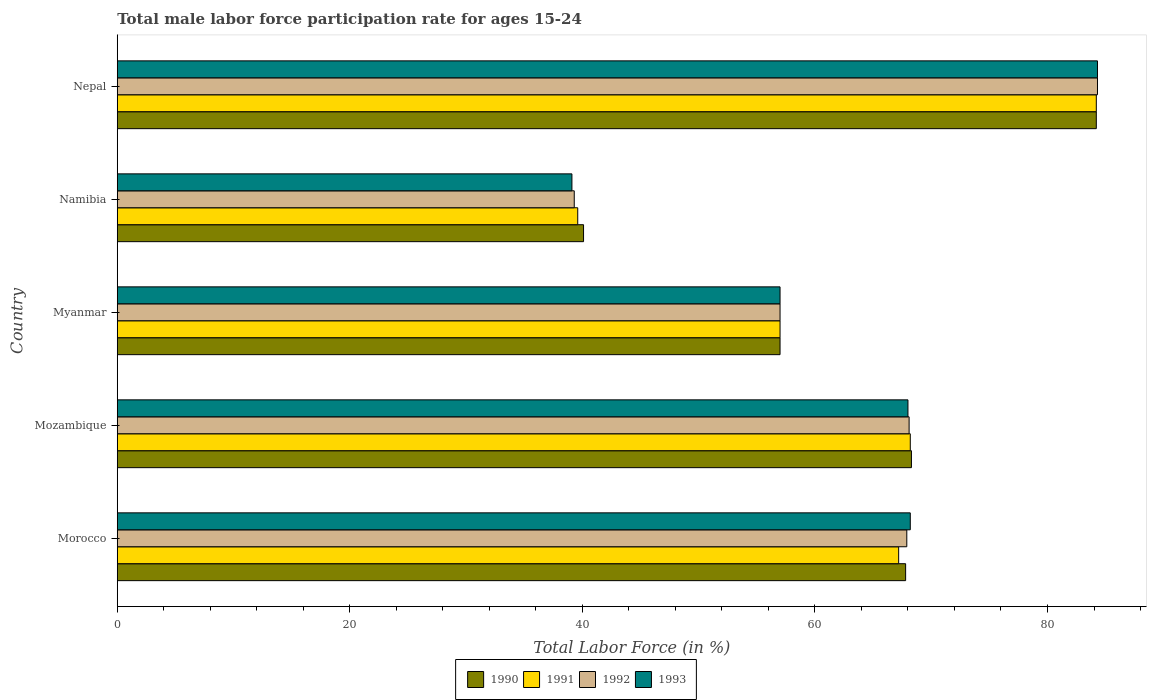How many groups of bars are there?
Offer a terse response. 5. Are the number of bars per tick equal to the number of legend labels?
Your answer should be very brief. Yes. How many bars are there on the 3rd tick from the bottom?
Ensure brevity in your answer.  4. What is the label of the 2nd group of bars from the top?
Offer a terse response. Namibia. In how many cases, is the number of bars for a given country not equal to the number of legend labels?
Provide a short and direct response. 0. What is the male labor force participation rate in 1990 in Mozambique?
Your answer should be very brief. 68.3. Across all countries, what is the maximum male labor force participation rate in 1990?
Provide a succinct answer. 84.2. Across all countries, what is the minimum male labor force participation rate in 1992?
Your answer should be compact. 39.3. In which country was the male labor force participation rate in 1992 maximum?
Provide a succinct answer. Nepal. In which country was the male labor force participation rate in 1991 minimum?
Keep it short and to the point. Namibia. What is the total male labor force participation rate in 1993 in the graph?
Give a very brief answer. 316.6. What is the difference between the male labor force participation rate in 1993 in Morocco and that in Namibia?
Make the answer very short. 29.1. What is the difference between the male labor force participation rate in 1992 in Mozambique and the male labor force participation rate in 1993 in Myanmar?
Make the answer very short. 11.1. What is the average male labor force participation rate in 1991 per country?
Your answer should be very brief. 63.24. In how many countries, is the male labor force participation rate in 1993 greater than 84 %?
Keep it short and to the point. 1. What is the ratio of the male labor force participation rate in 1990 in Morocco to that in Nepal?
Provide a short and direct response. 0.81. Is the difference between the male labor force participation rate in 1992 in Morocco and Myanmar greater than the difference between the male labor force participation rate in 1993 in Morocco and Myanmar?
Offer a very short reply. No. What is the difference between the highest and the lowest male labor force participation rate in 1990?
Make the answer very short. 44.1. In how many countries, is the male labor force participation rate in 1991 greater than the average male labor force participation rate in 1991 taken over all countries?
Provide a succinct answer. 3. Is the sum of the male labor force participation rate in 1991 in Myanmar and Namibia greater than the maximum male labor force participation rate in 1992 across all countries?
Provide a short and direct response. Yes. What does the 4th bar from the top in Myanmar represents?
Give a very brief answer. 1990. Is it the case that in every country, the sum of the male labor force participation rate in 1991 and male labor force participation rate in 1990 is greater than the male labor force participation rate in 1992?
Your response must be concise. Yes. How many countries are there in the graph?
Offer a terse response. 5. What is the difference between two consecutive major ticks on the X-axis?
Make the answer very short. 20. Does the graph contain any zero values?
Your answer should be very brief. No. Where does the legend appear in the graph?
Give a very brief answer. Bottom center. What is the title of the graph?
Provide a short and direct response. Total male labor force participation rate for ages 15-24. What is the label or title of the X-axis?
Your answer should be very brief. Total Labor Force (in %). What is the Total Labor Force (in %) of 1990 in Morocco?
Offer a terse response. 67.8. What is the Total Labor Force (in %) of 1991 in Morocco?
Your response must be concise. 67.2. What is the Total Labor Force (in %) in 1992 in Morocco?
Provide a succinct answer. 67.9. What is the Total Labor Force (in %) of 1993 in Morocco?
Offer a terse response. 68.2. What is the Total Labor Force (in %) of 1990 in Mozambique?
Provide a short and direct response. 68.3. What is the Total Labor Force (in %) of 1991 in Mozambique?
Make the answer very short. 68.2. What is the Total Labor Force (in %) in 1992 in Mozambique?
Offer a terse response. 68.1. What is the Total Labor Force (in %) of 1990 in Myanmar?
Provide a short and direct response. 57. What is the Total Labor Force (in %) of 1991 in Myanmar?
Offer a very short reply. 57. What is the Total Labor Force (in %) in 1993 in Myanmar?
Your answer should be compact. 57. What is the Total Labor Force (in %) of 1990 in Namibia?
Your answer should be compact. 40.1. What is the Total Labor Force (in %) in 1991 in Namibia?
Keep it short and to the point. 39.6. What is the Total Labor Force (in %) of 1992 in Namibia?
Provide a succinct answer. 39.3. What is the Total Labor Force (in %) of 1993 in Namibia?
Your answer should be compact. 39.1. What is the Total Labor Force (in %) in 1990 in Nepal?
Provide a succinct answer. 84.2. What is the Total Labor Force (in %) in 1991 in Nepal?
Give a very brief answer. 84.2. What is the Total Labor Force (in %) of 1992 in Nepal?
Offer a very short reply. 84.3. What is the Total Labor Force (in %) of 1993 in Nepal?
Offer a very short reply. 84.3. Across all countries, what is the maximum Total Labor Force (in %) in 1990?
Offer a terse response. 84.2. Across all countries, what is the maximum Total Labor Force (in %) of 1991?
Provide a short and direct response. 84.2. Across all countries, what is the maximum Total Labor Force (in %) in 1992?
Your answer should be very brief. 84.3. Across all countries, what is the maximum Total Labor Force (in %) of 1993?
Offer a very short reply. 84.3. Across all countries, what is the minimum Total Labor Force (in %) of 1990?
Your answer should be very brief. 40.1. Across all countries, what is the minimum Total Labor Force (in %) of 1991?
Your answer should be compact. 39.6. Across all countries, what is the minimum Total Labor Force (in %) in 1992?
Make the answer very short. 39.3. Across all countries, what is the minimum Total Labor Force (in %) of 1993?
Ensure brevity in your answer.  39.1. What is the total Total Labor Force (in %) of 1990 in the graph?
Offer a terse response. 317.4. What is the total Total Labor Force (in %) of 1991 in the graph?
Keep it short and to the point. 316.2. What is the total Total Labor Force (in %) of 1992 in the graph?
Give a very brief answer. 316.6. What is the total Total Labor Force (in %) in 1993 in the graph?
Your response must be concise. 316.6. What is the difference between the Total Labor Force (in %) in 1991 in Morocco and that in Mozambique?
Provide a succinct answer. -1. What is the difference between the Total Labor Force (in %) in 1990 in Morocco and that in Myanmar?
Offer a terse response. 10.8. What is the difference between the Total Labor Force (in %) of 1990 in Morocco and that in Namibia?
Provide a short and direct response. 27.7. What is the difference between the Total Labor Force (in %) of 1991 in Morocco and that in Namibia?
Ensure brevity in your answer.  27.6. What is the difference between the Total Labor Force (in %) in 1992 in Morocco and that in Namibia?
Your answer should be very brief. 28.6. What is the difference between the Total Labor Force (in %) of 1993 in Morocco and that in Namibia?
Ensure brevity in your answer.  29.1. What is the difference between the Total Labor Force (in %) of 1990 in Morocco and that in Nepal?
Offer a very short reply. -16.4. What is the difference between the Total Labor Force (in %) in 1992 in Morocco and that in Nepal?
Ensure brevity in your answer.  -16.4. What is the difference between the Total Labor Force (in %) of 1993 in Morocco and that in Nepal?
Make the answer very short. -16.1. What is the difference between the Total Labor Force (in %) in 1992 in Mozambique and that in Myanmar?
Offer a very short reply. 11.1. What is the difference between the Total Labor Force (in %) in 1993 in Mozambique and that in Myanmar?
Provide a short and direct response. 11. What is the difference between the Total Labor Force (in %) of 1990 in Mozambique and that in Namibia?
Provide a succinct answer. 28.2. What is the difference between the Total Labor Force (in %) in 1991 in Mozambique and that in Namibia?
Offer a terse response. 28.6. What is the difference between the Total Labor Force (in %) in 1992 in Mozambique and that in Namibia?
Give a very brief answer. 28.8. What is the difference between the Total Labor Force (in %) of 1993 in Mozambique and that in Namibia?
Your response must be concise. 28.9. What is the difference between the Total Labor Force (in %) of 1990 in Mozambique and that in Nepal?
Give a very brief answer. -15.9. What is the difference between the Total Labor Force (in %) in 1992 in Mozambique and that in Nepal?
Your response must be concise. -16.2. What is the difference between the Total Labor Force (in %) of 1993 in Mozambique and that in Nepal?
Your answer should be very brief. -16.3. What is the difference between the Total Labor Force (in %) of 1991 in Myanmar and that in Namibia?
Offer a terse response. 17.4. What is the difference between the Total Labor Force (in %) in 1992 in Myanmar and that in Namibia?
Keep it short and to the point. 17.7. What is the difference between the Total Labor Force (in %) of 1990 in Myanmar and that in Nepal?
Ensure brevity in your answer.  -27.2. What is the difference between the Total Labor Force (in %) in 1991 in Myanmar and that in Nepal?
Your answer should be very brief. -27.2. What is the difference between the Total Labor Force (in %) of 1992 in Myanmar and that in Nepal?
Provide a short and direct response. -27.3. What is the difference between the Total Labor Force (in %) in 1993 in Myanmar and that in Nepal?
Ensure brevity in your answer.  -27.3. What is the difference between the Total Labor Force (in %) of 1990 in Namibia and that in Nepal?
Your answer should be very brief. -44.1. What is the difference between the Total Labor Force (in %) in 1991 in Namibia and that in Nepal?
Keep it short and to the point. -44.6. What is the difference between the Total Labor Force (in %) of 1992 in Namibia and that in Nepal?
Offer a terse response. -45. What is the difference between the Total Labor Force (in %) in 1993 in Namibia and that in Nepal?
Provide a succinct answer. -45.2. What is the difference between the Total Labor Force (in %) in 1990 in Morocco and the Total Labor Force (in %) in 1991 in Mozambique?
Provide a short and direct response. -0.4. What is the difference between the Total Labor Force (in %) of 1991 in Morocco and the Total Labor Force (in %) of 1992 in Mozambique?
Provide a succinct answer. -0.9. What is the difference between the Total Labor Force (in %) in 1992 in Morocco and the Total Labor Force (in %) in 1993 in Mozambique?
Provide a succinct answer. -0.1. What is the difference between the Total Labor Force (in %) of 1990 in Morocco and the Total Labor Force (in %) of 1993 in Myanmar?
Keep it short and to the point. 10.8. What is the difference between the Total Labor Force (in %) of 1991 in Morocco and the Total Labor Force (in %) of 1992 in Myanmar?
Make the answer very short. 10.2. What is the difference between the Total Labor Force (in %) in 1991 in Morocco and the Total Labor Force (in %) in 1993 in Myanmar?
Provide a succinct answer. 10.2. What is the difference between the Total Labor Force (in %) in 1990 in Morocco and the Total Labor Force (in %) in 1991 in Namibia?
Make the answer very short. 28.2. What is the difference between the Total Labor Force (in %) of 1990 in Morocco and the Total Labor Force (in %) of 1992 in Namibia?
Make the answer very short. 28.5. What is the difference between the Total Labor Force (in %) of 1990 in Morocco and the Total Labor Force (in %) of 1993 in Namibia?
Provide a succinct answer. 28.7. What is the difference between the Total Labor Force (in %) of 1991 in Morocco and the Total Labor Force (in %) of 1992 in Namibia?
Your response must be concise. 27.9. What is the difference between the Total Labor Force (in %) in 1991 in Morocco and the Total Labor Force (in %) in 1993 in Namibia?
Ensure brevity in your answer.  28.1. What is the difference between the Total Labor Force (in %) of 1992 in Morocco and the Total Labor Force (in %) of 1993 in Namibia?
Offer a terse response. 28.8. What is the difference between the Total Labor Force (in %) in 1990 in Morocco and the Total Labor Force (in %) in 1991 in Nepal?
Your answer should be very brief. -16.4. What is the difference between the Total Labor Force (in %) in 1990 in Morocco and the Total Labor Force (in %) in 1992 in Nepal?
Make the answer very short. -16.5. What is the difference between the Total Labor Force (in %) in 1990 in Morocco and the Total Labor Force (in %) in 1993 in Nepal?
Your response must be concise. -16.5. What is the difference between the Total Labor Force (in %) of 1991 in Morocco and the Total Labor Force (in %) of 1992 in Nepal?
Keep it short and to the point. -17.1. What is the difference between the Total Labor Force (in %) in 1991 in Morocco and the Total Labor Force (in %) in 1993 in Nepal?
Ensure brevity in your answer.  -17.1. What is the difference between the Total Labor Force (in %) in 1992 in Morocco and the Total Labor Force (in %) in 1993 in Nepal?
Offer a terse response. -16.4. What is the difference between the Total Labor Force (in %) of 1990 in Mozambique and the Total Labor Force (in %) of 1991 in Myanmar?
Your response must be concise. 11.3. What is the difference between the Total Labor Force (in %) in 1990 in Mozambique and the Total Labor Force (in %) in 1992 in Myanmar?
Ensure brevity in your answer.  11.3. What is the difference between the Total Labor Force (in %) of 1991 in Mozambique and the Total Labor Force (in %) of 1992 in Myanmar?
Ensure brevity in your answer.  11.2. What is the difference between the Total Labor Force (in %) in 1991 in Mozambique and the Total Labor Force (in %) in 1993 in Myanmar?
Make the answer very short. 11.2. What is the difference between the Total Labor Force (in %) in 1990 in Mozambique and the Total Labor Force (in %) in 1991 in Namibia?
Offer a terse response. 28.7. What is the difference between the Total Labor Force (in %) of 1990 in Mozambique and the Total Labor Force (in %) of 1992 in Namibia?
Provide a succinct answer. 29. What is the difference between the Total Labor Force (in %) in 1990 in Mozambique and the Total Labor Force (in %) in 1993 in Namibia?
Provide a short and direct response. 29.2. What is the difference between the Total Labor Force (in %) of 1991 in Mozambique and the Total Labor Force (in %) of 1992 in Namibia?
Offer a very short reply. 28.9. What is the difference between the Total Labor Force (in %) in 1991 in Mozambique and the Total Labor Force (in %) in 1993 in Namibia?
Offer a terse response. 29.1. What is the difference between the Total Labor Force (in %) of 1992 in Mozambique and the Total Labor Force (in %) of 1993 in Namibia?
Your answer should be very brief. 29. What is the difference between the Total Labor Force (in %) of 1990 in Mozambique and the Total Labor Force (in %) of 1991 in Nepal?
Ensure brevity in your answer.  -15.9. What is the difference between the Total Labor Force (in %) of 1990 in Mozambique and the Total Labor Force (in %) of 1992 in Nepal?
Your response must be concise. -16. What is the difference between the Total Labor Force (in %) in 1990 in Mozambique and the Total Labor Force (in %) in 1993 in Nepal?
Your response must be concise. -16. What is the difference between the Total Labor Force (in %) of 1991 in Mozambique and the Total Labor Force (in %) of 1992 in Nepal?
Your answer should be very brief. -16.1. What is the difference between the Total Labor Force (in %) of 1991 in Mozambique and the Total Labor Force (in %) of 1993 in Nepal?
Keep it short and to the point. -16.1. What is the difference between the Total Labor Force (in %) in 1992 in Mozambique and the Total Labor Force (in %) in 1993 in Nepal?
Give a very brief answer. -16.2. What is the difference between the Total Labor Force (in %) of 1990 in Myanmar and the Total Labor Force (in %) of 1991 in Namibia?
Offer a very short reply. 17.4. What is the difference between the Total Labor Force (in %) of 1990 in Myanmar and the Total Labor Force (in %) of 1992 in Namibia?
Offer a terse response. 17.7. What is the difference between the Total Labor Force (in %) in 1990 in Myanmar and the Total Labor Force (in %) in 1991 in Nepal?
Provide a succinct answer. -27.2. What is the difference between the Total Labor Force (in %) of 1990 in Myanmar and the Total Labor Force (in %) of 1992 in Nepal?
Make the answer very short. -27.3. What is the difference between the Total Labor Force (in %) of 1990 in Myanmar and the Total Labor Force (in %) of 1993 in Nepal?
Give a very brief answer. -27.3. What is the difference between the Total Labor Force (in %) of 1991 in Myanmar and the Total Labor Force (in %) of 1992 in Nepal?
Provide a short and direct response. -27.3. What is the difference between the Total Labor Force (in %) of 1991 in Myanmar and the Total Labor Force (in %) of 1993 in Nepal?
Offer a terse response. -27.3. What is the difference between the Total Labor Force (in %) in 1992 in Myanmar and the Total Labor Force (in %) in 1993 in Nepal?
Offer a very short reply. -27.3. What is the difference between the Total Labor Force (in %) in 1990 in Namibia and the Total Labor Force (in %) in 1991 in Nepal?
Provide a short and direct response. -44.1. What is the difference between the Total Labor Force (in %) of 1990 in Namibia and the Total Labor Force (in %) of 1992 in Nepal?
Ensure brevity in your answer.  -44.2. What is the difference between the Total Labor Force (in %) in 1990 in Namibia and the Total Labor Force (in %) in 1993 in Nepal?
Offer a very short reply. -44.2. What is the difference between the Total Labor Force (in %) of 1991 in Namibia and the Total Labor Force (in %) of 1992 in Nepal?
Your response must be concise. -44.7. What is the difference between the Total Labor Force (in %) of 1991 in Namibia and the Total Labor Force (in %) of 1993 in Nepal?
Ensure brevity in your answer.  -44.7. What is the difference between the Total Labor Force (in %) of 1992 in Namibia and the Total Labor Force (in %) of 1993 in Nepal?
Your response must be concise. -45. What is the average Total Labor Force (in %) in 1990 per country?
Ensure brevity in your answer.  63.48. What is the average Total Labor Force (in %) in 1991 per country?
Give a very brief answer. 63.24. What is the average Total Labor Force (in %) in 1992 per country?
Make the answer very short. 63.32. What is the average Total Labor Force (in %) of 1993 per country?
Provide a short and direct response. 63.32. What is the difference between the Total Labor Force (in %) in 1990 and Total Labor Force (in %) in 1992 in Morocco?
Offer a terse response. -0.1. What is the difference between the Total Labor Force (in %) of 1990 and Total Labor Force (in %) of 1993 in Morocco?
Give a very brief answer. -0.4. What is the difference between the Total Labor Force (in %) in 1992 and Total Labor Force (in %) in 1993 in Morocco?
Provide a succinct answer. -0.3. What is the difference between the Total Labor Force (in %) in 1992 and Total Labor Force (in %) in 1993 in Mozambique?
Provide a short and direct response. 0.1. What is the difference between the Total Labor Force (in %) of 1990 and Total Labor Force (in %) of 1992 in Myanmar?
Make the answer very short. 0. What is the difference between the Total Labor Force (in %) in 1990 and Total Labor Force (in %) in 1993 in Myanmar?
Provide a short and direct response. 0. What is the difference between the Total Labor Force (in %) in 1991 and Total Labor Force (in %) in 1992 in Myanmar?
Ensure brevity in your answer.  0. What is the difference between the Total Labor Force (in %) in 1991 and Total Labor Force (in %) in 1993 in Myanmar?
Offer a very short reply. 0. What is the difference between the Total Labor Force (in %) of 1990 and Total Labor Force (in %) of 1993 in Namibia?
Provide a short and direct response. 1. What is the difference between the Total Labor Force (in %) of 1991 and Total Labor Force (in %) of 1992 in Namibia?
Give a very brief answer. 0.3. What is the difference between the Total Labor Force (in %) of 1991 and Total Labor Force (in %) of 1993 in Namibia?
Give a very brief answer. 0.5. What is the difference between the Total Labor Force (in %) of 1990 and Total Labor Force (in %) of 1991 in Nepal?
Your answer should be very brief. 0. What is the difference between the Total Labor Force (in %) in 1991 and Total Labor Force (in %) in 1992 in Nepal?
Provide a short and direct response. -0.1. What is the difference between the Total Labor Force (in %) of 1992 and Total Labor Force (in %) of 1993 in Nepal?
Your answer should be compact. 0. What is the ratio of the Total Labor Force (in %) in 1990 in Morocco to that in Mozambique?
Your answer should be compact. 0.99. What is the ratio of the Total Labor Force (in %) in 1991 in Morocco to that in Mozambique?
Your answer should be compact. 0.99. What is the ratio of the Total Labor Force (in %) in 1993 in Morocco to that in Mozambique?
Keep it short and to the point. 1. What is the ratio of the Total Labor Force (in %) in 1990 in Morocco to that in Myanmar?
Offer a terse response. 1.19. What is the ratio of the Total Labor Force (in %) in 1991 in Morocco to that in Myanmar?
Provide a succinct answer. 1.18. What is the ratio of the Total Labor Force (in %) of 1992 in Morocco to that in Myanmar?
Provide a succinct answer. 1.19. What is the ratio of the Total Labor Force (in %) in 1993 in Morocco to that in Myanmar?
Make the answer very short. 1.2. What is the ratio of the Total Labor Force (in %) of 1990 in Morocco to that in Namibia?
Offer a terse response. 1.69. What is the ratio of the Total Labor Force (in %) of 1991 in Morocco to that in Namibia?
Offer a very short reply. 1.7. What is the ratio of the Total Labor Force (in %) of 1992 in Morocco to that in Namibia?
Keep it short and to the point. 1.73. What is the ratio of the Total Labor Force (in %) of 1993 in Morocco to that in Namibia?
Offer a very short reply. 1.74. What is the ratio of the Total Labor Force (in %) in 1990 in Morocco to that in Nepal?
Keep it short and to the point. 0.81. What is the ratio of the Total Labor Force (in %) in 1991 in Morocco to that in Nepal?
Give a very brief answer. 0.8. What is the ratio of the Total Labor Force (in %) in 1992 in Morocco to that in Nepal?
Provide a succinct answer. 0.81. What is the ratio of the Total Labor Force (in %) of 1993 in Morocco to that in Nepal?
Give a very brief answer. 0.81. What is the ratio of the Total Labor Force (in %) in 1990 in Mozambique to that in Myanmar?
Provide a short and direct response. 1.2. What is the ratio of the Total Labor Force (in %) in 1991 in Mozambique to that in Myanmar?
Offer a terse response. 1.2. What is the ratio of the Total Labor Force (in %) in 1992 in Mozambique to that in Myanmar?
Keep it short and to the point. 1.19. What is the ratio of the Total Labor Force (in %) in 1993 in Mozambique to that in Myanmar?
Ensure brevity in your answer.  1.19. What is the ratio of the Total Labor Force (in %) of 1990 in Mozambique to that in Namibia?
Offer a very short reply. 1.7. What is the ratio of the Total Labor Force (in %) in 1991 in Mozambique to that in Namibia?
Ensure brevity in your answer.  1.72. What is the ratio of the Total Labor Force (in %) of 1992 in Mozambique to that in Namibia?
Offer a very short reply. 1.73. What is the ratio of the Total Labor Force (in %) in 1993 in Mozambique to that in Namibia?
Your answer should be very brief. 1.74. What is the ratio of the Total Labor Force (in %) of 1990 in Mozambique to that in Nepal?
Offer a terse response. 0.81. What is the ratio of the Total Labor Force (in %) in 1991 in Mozambique to that in Nepal?
Keep it short and to the point. 0.81. What is the ratio of the Total Labor Force (in %) in 1992 in Mozambique to that in Nepal?
Give a very brief answer. 0.81. What is the ratio of the Total Labor Force (in %) in 1993 in Mozambique to that in Nepal?
Provide a short and direct response. 0.81. What is the ratio of the Total Labor Force (in %) of 1990 in Myanmar to that in Namibia?
Your response must be concise. 1.42. What is the ratio of the Total Labor Force (in %) of 1991 in Myanmar to that in Namibia?
Provide a succinct answer. 1.44. What is the ratio of the Total Labor Force (in %) in 1992 in Myanmar to that in Namibia?
Your answer should be compact. 1.45. What is the ratio of the Total Labor Force (in %) of 1993 in Myanmar to that in Namibia?
Make the answer very short. 1.46. What is the ratio of the Total Labor Force (in %) in 1990 in Myanmar to that in Nepal?
Provide a succinct answer. 0.68. What is the ratio of the Total Labor Force (in %) in 1991 in Myanmar to that in Nepal?
Your response must be concise. 0.68. What is the ratio of the Total Labor Force (in %) of 1992 in Myanmar to that in Nepal?
Make the answer very short. 0.68. What is the ratio of the Total Labor Force (in %) in 1993 in Myanmar to that in Nepal?
Ensure brevity in your answer.  0.68. What is the ratio of the Total Labor Force (in %) of 1990 in Namibia to that in Nepal?
Provide a succinct answer. 0.48. What is the ratio of the Total Labor Force (in %) of 1991 in Namibia to that in Nepal?
Offer a very short reply. 0.47. What is the ratio of the Total Labor Force (in %) in 1992 in Namibia to that in Nepal?
Provide a succinct answer. 0.47. What is the ratio of the Total Labor Force (in %) of 1993 in Namibia to that in Nepal?
Ensure brevity in your answer.  0.46. What is the difference between the highest and the second highest Total Labor Force (in %) of 1990?
Offer a terse response. 15.9. What is the difference between the highest and the second highest Total Labor Force (in %) of 1991?
Ensure brevity in your answer.  16. What is the difference between the highest and the lowest Total Labor Force (in %) in 1990?
Your response must be concise. 44.1. What is the difference between the highest and the lowest Total Labor Force (in %) of 1991?
Provide a short and direct response. 44.6. What is the difference between the highest and the lowest Total Labor Force (in %) of 1992?
Make the answer very short. 45. What is the difference between the highest and the lowest Total Labor Force (in %) in 1993?
Offer a very short reply. 45.2. 